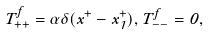Convert formula to latex. <formula><loc_0><loc_0><loc_500><loc_500>T _ { + + } ^ { f } = \alpha \delta ( x ^ { + } - x _ { 1 } ^ { + } ) , T _ { - - } ^ { f } = 0 ,</formula> 